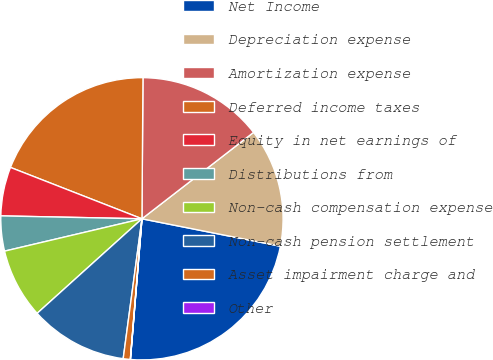<chart> <loc_0><loc_0><loc_500><loc_500><pie_chart><fcel>Net Income<fcel>Depreciation expense<fcel>Amortization expense<fcel>Deferred income taxes<fcel>Equity in net earnings of<fcel>Distributions from<fcel>Non-cash compensation expense<fcel>Non-cash pension settlement<fcel>Asset impairment charge and<fcel>Other<nl><fcel>23.19%<fcel>13.6%<fcel>14.4%<fcel>19.19%<fcel>5.6%<fcel>4.01%<fcel>8.0%<fcel>11.2%<fcel>0.81%<fcel>0.01%<nl></chart> 